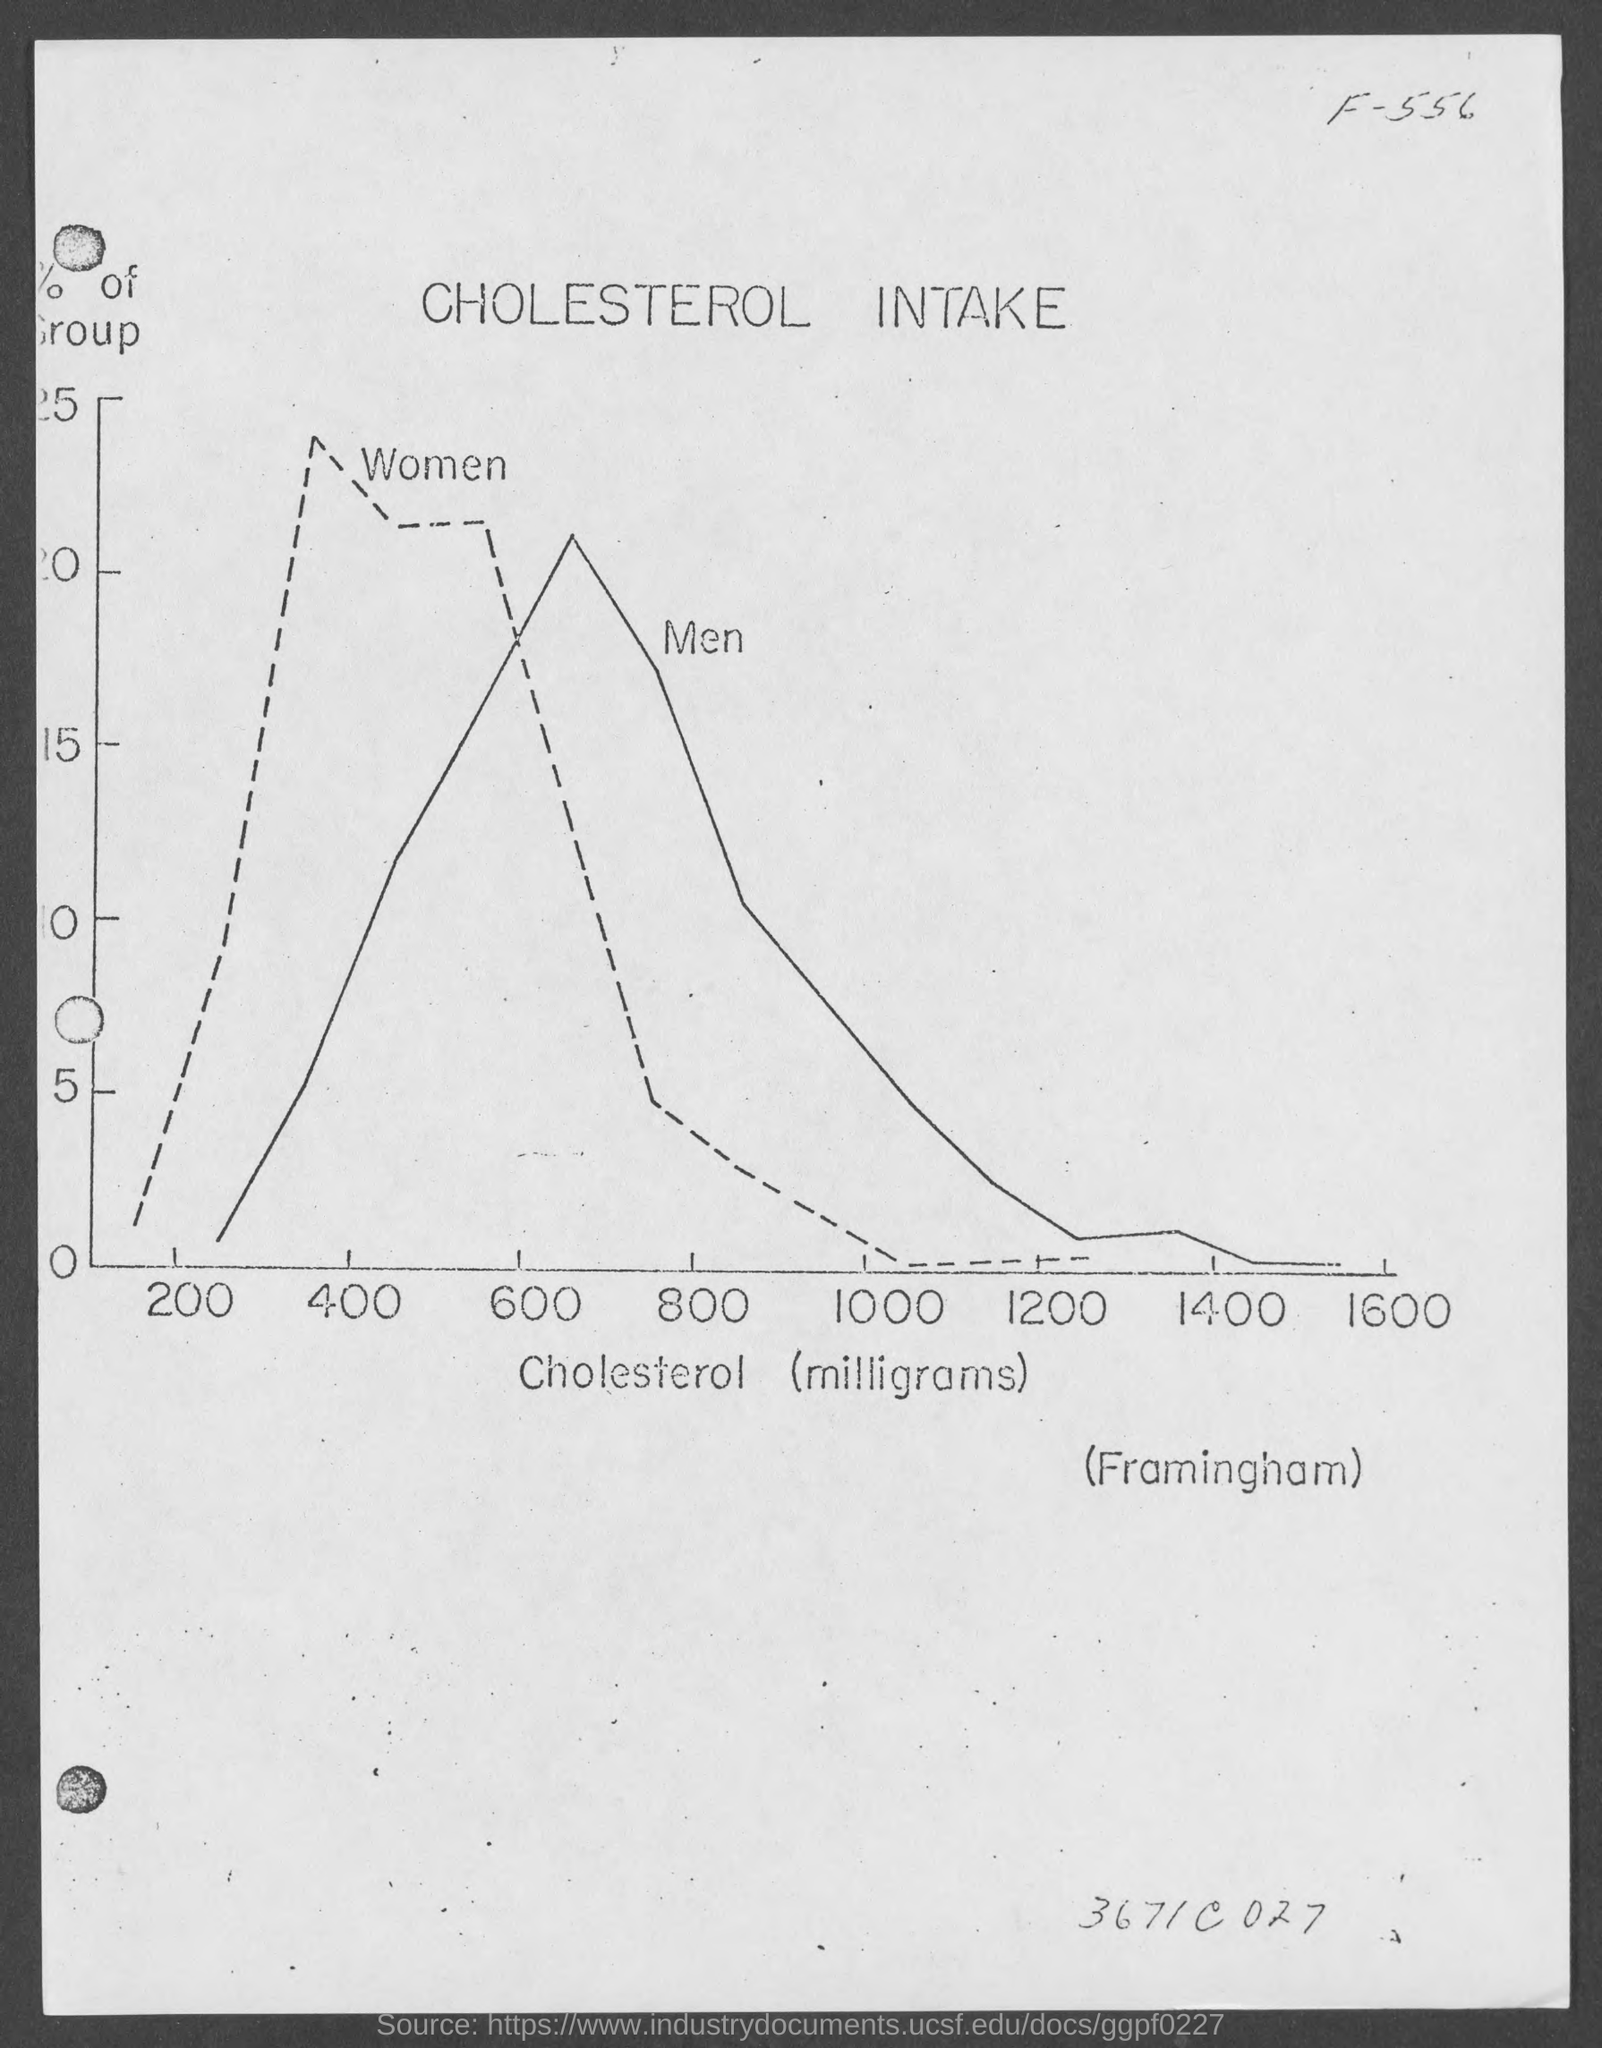Outline some significant characteristics in this image. The variable on the X axis of the graph is cholesterol, in milligrams. The title of the graph is 'Cholesterol Intake'. The solid line represents men. The group represented by the dotted line is women. 